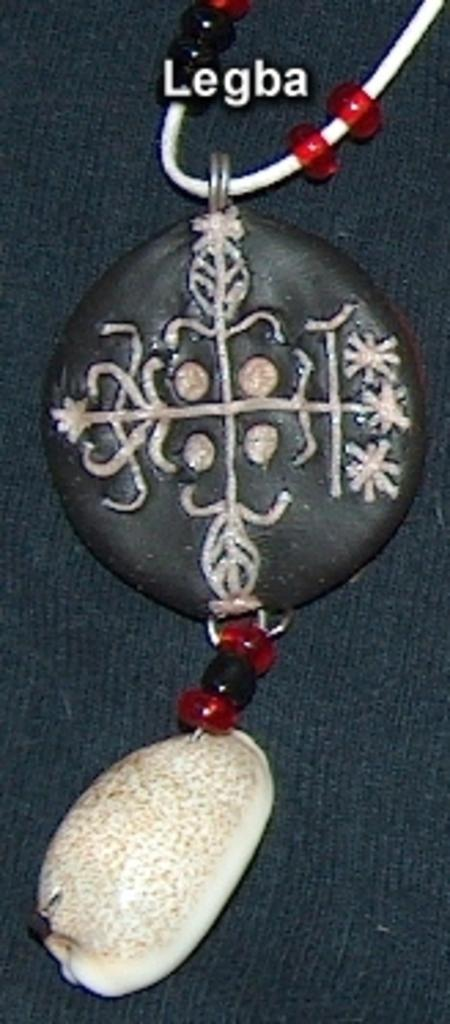What is the main subject of the image? The main subject of the image is a locket. Where is the locket located in the image? The locket is on an object. Is there any text visible in the image? Yes, there is text on the top side of the image. Can you tell me how many dimes are placed next to the locket in the image? There is no mention of dimes in the image, so it cannot be determined if any are present. 